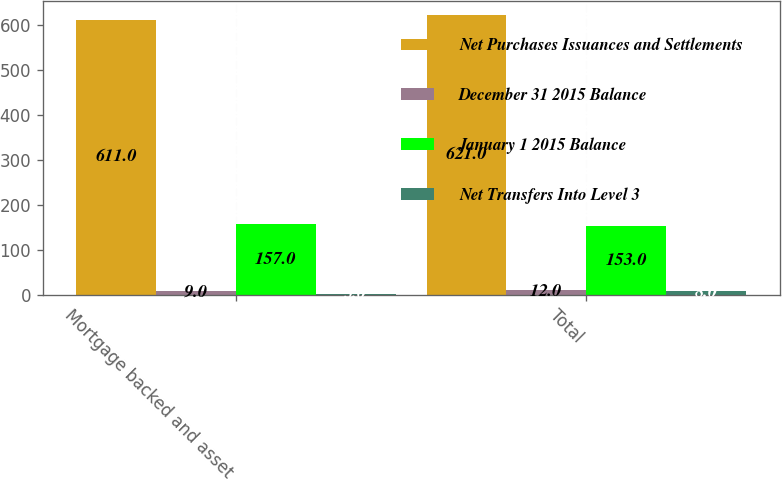Convert chart to OTSL. <chart><loc_0><loc_0><loc_500><loc_500><stacked_bar_chart><ecel><fcel>Mortgage backed and asset<fcel>Total<nl><fcel>Net Purchases Issuances and Settlements<fcel>611<fcel>621<nl><fcel>December 31 2015 Balance<fcel>9<fcel>12<nl><fcel>January 1 2015 Balance<fcel>157<fcel>153<nl><fcel>Net Transfers Into Level 3<fcel>3<fcel>8<nl></chart> 